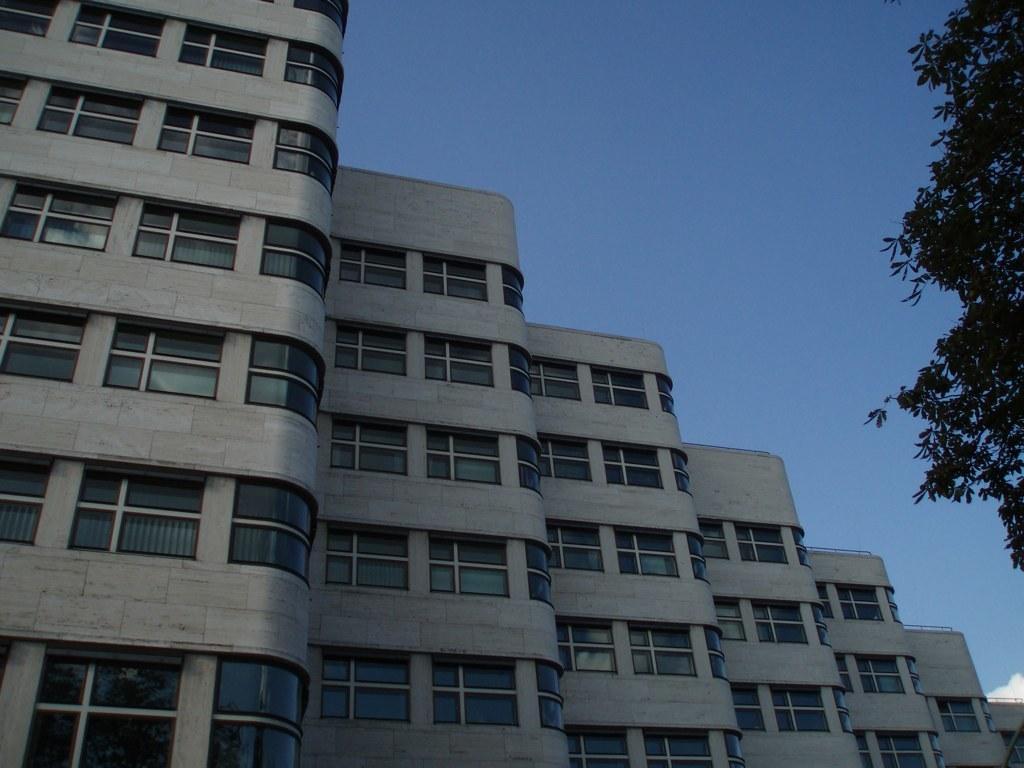Can you describe this image briefly? In this picture I can see number of buildings in front and on the right side of this picture I can see the leaves. In the background I can see the sky. 